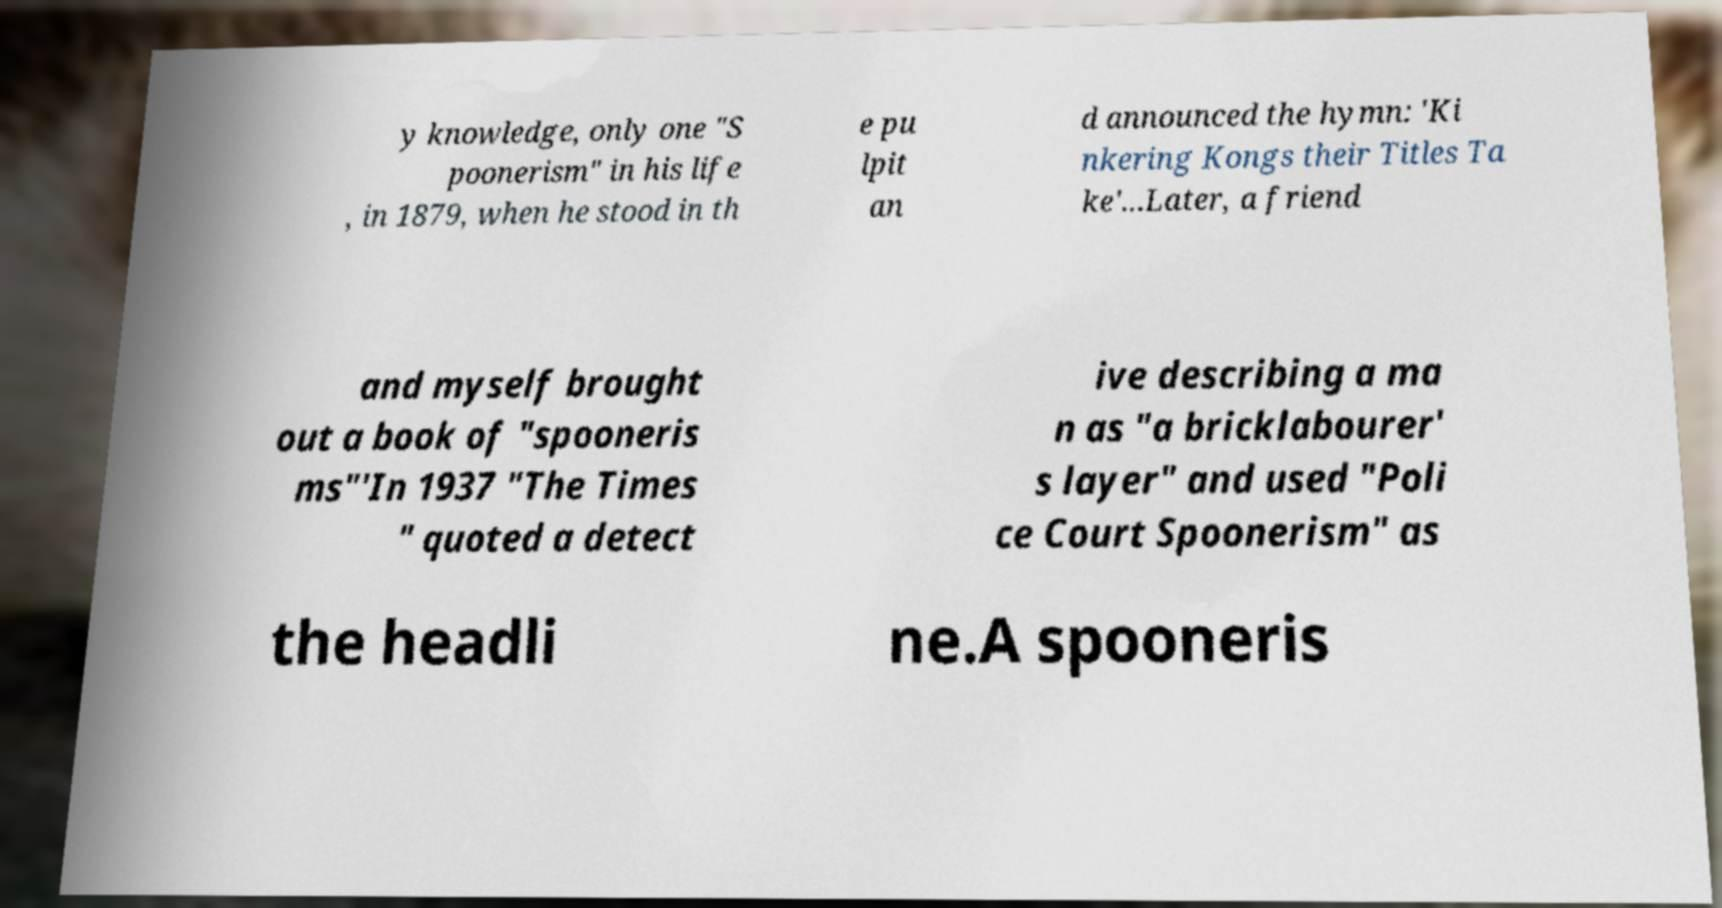There's text embedded in this image that I need extracted. Can you transcribe it verbatim? y knowledge, only one "S poonerism" in his life , in 1879, when he stood in th e pu lpit an d announced the hymn: 'Ki nkering Kongs their Titles Ta ke'...Later, a friend and myself brought out a book of "spooneris ms"'In 1937 "The Times " quoted a detect ive describing a ma n as "a bricklabourer' s layer" and used "Poli ce Court Spoonerism" as the headli ne.A spooneris 